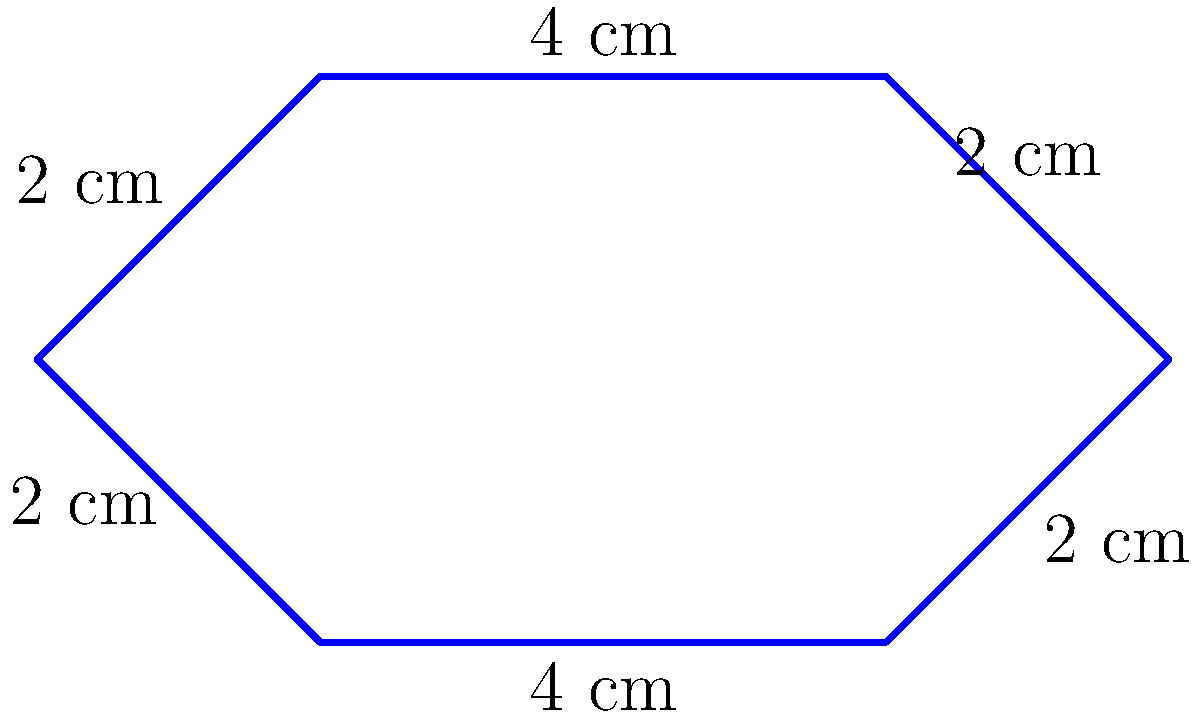You're designing a star-shaped dressing room sign for your favorite comedian's show. The sign has 6 sides with lengths as shown in the diagram. What is the perimeter of the sign in centimeters? Let's calculate the perimeter step by step:

1. The perimeter of a shape is the sum of all its side lengths.

2. Looking at the star shape, we can see:
   - Two sides are 4 cm long
   - Four sides are 2 cm long

3. Let's add up all the side lengths:
   $$(4 \text{ cm} \times 2) + (2 \text{ cm} \times 4) = 8 \text{ cm} + 8 \text{ cm} = 16 \text{ cm}$$

4. Therefore, the total perimeter of the star-shaped sign is 16 cm.
Answer: 16 cm 